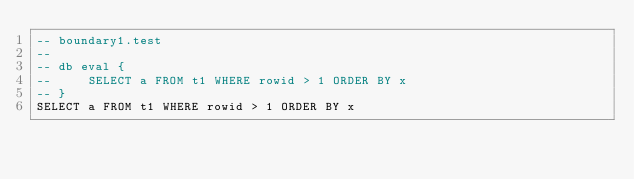<code> <loc_0><loc_0><loc_500><loc_500><_SQL_>-- boundary1.test
-- 
-- db eval {
--     SELECT a FROM t1 WHERE rowid > 1 ORDER BY x
-- }
SELECT a FROM t1 WHERE rowid > 1 ORDER BY x</code> 